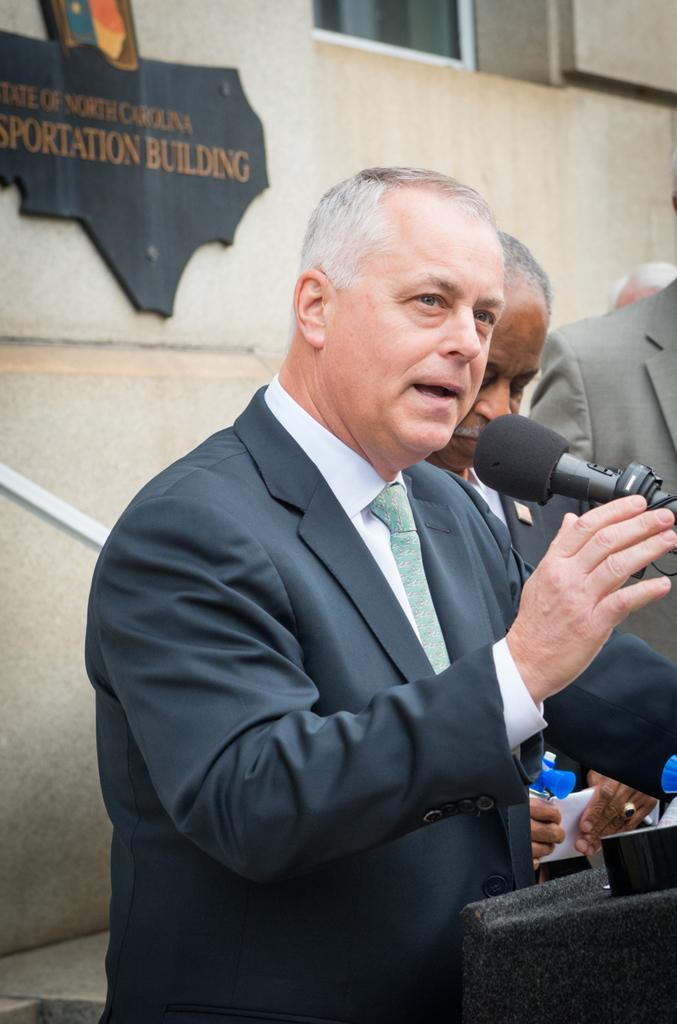Who is present in the image? There is a man in the image. What is the man wearing? The man is wearing a black suit. What is the man holding in his hand? The man is holding a mic in his hand. What other object can be seen in the image? There is a blackboard in the image. What type of drum can be seen on the man's chest in the image? There is no drum visible on the man's chest in the image. 